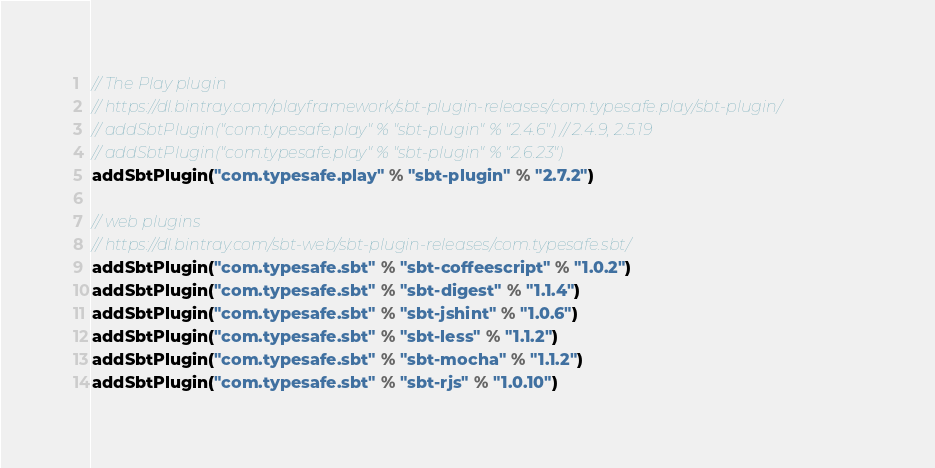<code> <loc_0><loc_0><loc_500><loc_500><_Scala_>// The Play plugin
// https://dl.bintray.com/playframework/sbt-plugin-releases/com.typesafe.play/sbt-plugin/
// addSbtPlugin("com.typesafe.play" % "sbt-plugin" % "2.4.6") // 2.4.9, 2.5.19
// addSbtPlugin("com.typesafe.play" % "sbt-plugin" % "2.6.23")
addSbtPlugin("com.typesafe.play" % "sbt-plugin" % "2.7.2")

// web plugins
// https://dl.bintray.com/sbt-web/sbt-plugin-releases/com.typesafe.sbt/
addSbtPlugin("com.typesafe.sbt" % "sbt-coffeescript" % "1.0.2")
addSbtPlugin("com.typesafe.sbt" % "sbt-digest" % "1.1.4")
addSbtPlugin("com.typesafe.sbt" % "sbt-jshint" % "1.0.6")
addSbtPlugin("com.typesafe.sbt" % "sbt-less" % "1.1.2")
addSbtPlugin("com.typesafe.sbt" % "sbt-mocha" % "1.1.2")
addSbtPlugin("com.typesafe.sbt" % "sbt-rjs" % "1.0.10")
</code> 